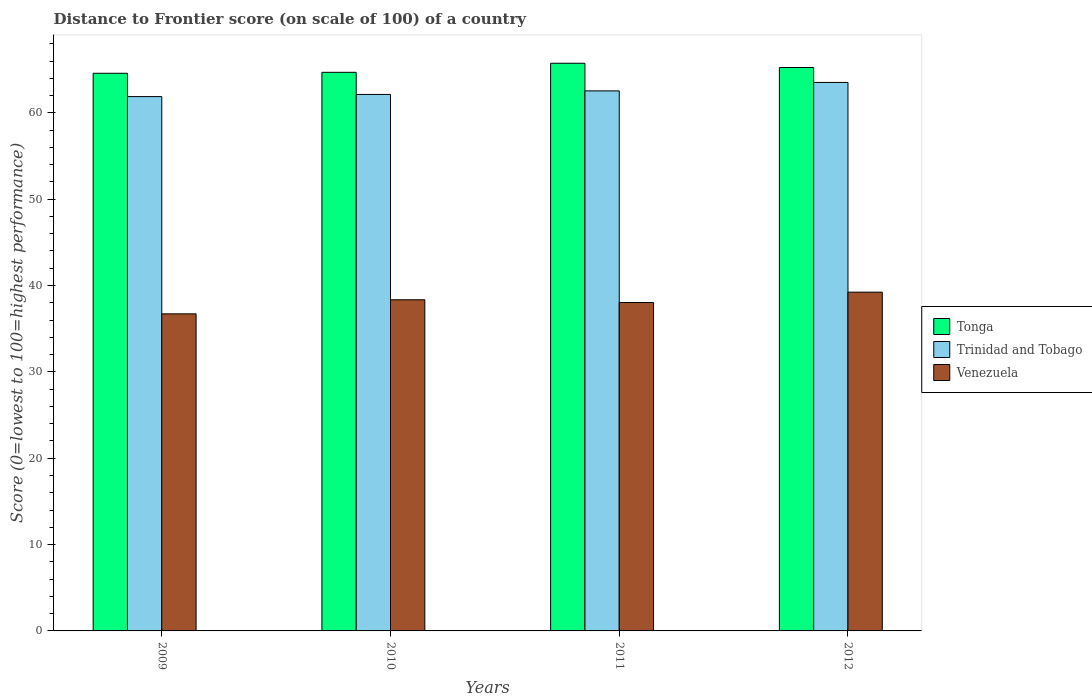How many bars are there on the 1st tick from the right?
Offer a very short reply. 3. What is the distance to frontier score of in Tonga in 2009?
Make the answer very short. 64.58. Across all years, what is the maximum distance to frontier score of in Trinidad and Tobago?
Provide a short and direct response. 63.52. Across all years, what is the minimum distance to frontier score of in Tonga?
Offer a very short reply. 64.58. In which year was the distance to frontier score of in Trinidad and Tobago maximum?
Your response must be concise. 2012. What is the total distance to frontier score of in Venezuela in the graph?
Offer a very short reply. 152.33. What is the difference between the distance to frontier score of in Venezuela in 2009 and that in 2012?
Offer a very short reply. -2.51. What is the difference between the distance to frontier score of in Trinidad and Tobago in 2009 and the distance to frontier score of in Venezuela in 2012?
Your answer should be very brief. 22.65. What is the average distance to frontier score of in Tonga per year?
Offer a very short reply. 65.06. In the year 2011, what is the difference between the distance to frontier score of in Venezuela and distance to frontier score of in Trinidad and Tobago?
Offer a terse response. -24.51. What is the ratio of the distance to frontier score of in Venezuela in 2009 to that in 2012?
Provide a short and direct response. 0.94. What is the difference between the highest and the second highest distance to frontier score of in Tonga?
Your answer should be compact. 0.49. What is the difference between the highest and the lowest distance to frontier score of in Venezuela?
Your answer should be very brief. 2.51. What does the 1st bar from the left in 2010 represents?
Offer a terse response. Tonga. What does the 1st bar from the right in 2010 represents?
Make the answer very short. Venezuela. Is it the case that in every year, the sum of the distance to frontier score of in Trinidad and Tobago and distance to frontier score of in Tonga is greater than the distance to frontier score of in Venezuela?
Your answer should be very brief. Yes. How many years are there in the graph?
Offer a terse response. 4. What is the difference between two consecutive major ticks on the Y-axis?
Your answer should be very brief. 10. Does the graph contain grids?
Provide a succinct answer. No. How are the legend labels stacked?
Offer a terse response. Vertical. What is the title of the graph?
Ensure brevity in your answer.  Distance to Frontier score (on scale of 100) of a country. Does "Algeria" appear as one of the legend labels in the graph?
Keep it short and to the point. No. What is the label or title of the Y-axis?
Offer a terse response. Score (0=lowest to 100=highest performance). What is the Score (0=lowest to 100=highest performance) of Tonga in 2009?
Offer a very short reply. 64.58. What is the Score (0=lowest to 100=highest performance) of Trinidad and Tobago in 2009?
Ensure brevity in your answer.  61.88. What is the Score (0=lowest to 100=highest performance) in Venezuela in 2009?
Give a very brief answer. 36.72. What is the Score (0=lowest to 100=highest performance) of Tonga in 2010?
Your answer should be very brief. 64.69. What is the Score (0=lowest to 100=highest performance) of Trinidad and Tobago in 2010?
Ensure brevity in your answer.  62.13. What is the Score (0=lowest to 100=highest performance) in Venezuela in 2010?
Your answer should be compact. 38.35. What is the Score (0=lowest to 100=highest performance) of Tonga in 2011?
Provide a succinct answer. 65.74. What is the Score (0=lowest to 100=highest performance) of Trinidad and Tobago in 2011?
Give a very brief answer. 62.54. What is the Score (0=lowest to 100=highest performance) of Venezuela in 2011?
Make the answer very short. 38.03. What is the Score (0=lowest to 100=highest performance) of Tonga in 2012?
Your answer should be compact. 65.25. What is the Score (0=lowest to 100=highest performance) of Trinidad and Tobago in 2012?
Your response must be concise. 63.52. What is the Score (0=lowest to 100=highest performance) of Venezuela in 2012?
Your answer should be compact. 39.23. Across all years, what is the maximum Score (0=lowest to 100=highest performance) of Tonga?
Keep it short and to the point. 65.74. Across all years, what is the maximum Score (0=lowest to 100=highest performance) of Trinidad and Tobago?
Offer a very short reply. 63.52. Across all years, what is the maximum Score (0=lowest to 100=highest performance) in Venezuela?
Provide a succinct answer. 39.23. Across all years, what is the minimum Score (0=lowest to 100=highest performance) of Tonga?
Ensure brevity in your answer.  64.58. Across all years, what is the minimum Score (0=lowest to 100=highest performance) of Trinidad and Tobago?
Make the answer very short. 61.88. Across all years, what is the minimum Score (0=lowest to 100=highest performance) of Venezuela?
Give a very brief answer. 36.72. What is the total Score (0=lowest to 100=highest performance) in Tonga in the graph?
Provide a succinct answer. 260.26. What is the total Score (0=lowest to 100=highest performance) of Trinidad and Tobago in the graph?
Keep it short and to the point. 250.07. What is the total Score (0=lowest to 100=highest performance) in Venezuela in the graph?
Ensure brevity in your answer.  152.33. What is the difference between the Score (0=lowest to 100=highest performance) in Tonga in 2009 and that in 2010?
Provide a short and direct response. -0.11. What is the difference between the Score (0=lowest to 100=highest performance) of Trinidad and Tobago in 2009 and that in 2010?
Make the answer very short. -0.25. What is the difference between the Score (0=lowest to 100=highest performance) in Venezuela in 2009 and that in 2010?
Provide a succinct answer. -1.63. What is the difference between the Score (0=lowest to 100=highest performance) of Tonga in 2009 and that in 2011?
Provide a succinct answer. -1.16. What is the difference between the Score (0=lowest to 100=highest performance) in Trinidad and Tobago in 2009 and that in 2011?
Offer a very short reply. -0.66. What is the difference between the Score (0=lowest to 100=highest performance) of Venezuela in 2009 and that in 2011?
Provide a succinct answer. -1.31. What is the difference between the Score (0=lowest to 100=highest performance) of Tonga in 2009 and that in 2012?
Your response must be concise. -0.67. What is the difference between the Score (0=lowest to 100=highest performance) in Trinidad and Tobago in 2009 and that in 2012?
Ensure brevity in your answer.  -1.64. What is the difference between the Score (0=lowest to 100=highest performance) in Venezuela in 2009 and that in 2012?
Provide a short and direct response. -2.51. What is the difference between the Score (0=lowest to 100=highest performance) of Tonga in 2010 and that in 2011?
Provide a succinct answer. -1.05. What is the difference between the Score (0=lowest to 100=highest performance) of Trinidad and Tobago in 2010 and that in 2011?
Your answer should be very brief. -0.41. What is the difference between the Score (0=lowest to 100=highest performance) of Venezuela in 2010 and that in 2011?
Make the answer very short. 0.32. What is the difference between the Score (0=lowest to 100=highest performance) of Tonga in 2010 and that in 2012?
Your answer should be compact. -0.56. What is the difference between the Score (0=lowest to 100=highest performance) in Trinidad and Tobago in 2010 and that in 2012?
Your answer should be very brief. -1.39. What is the difference between the Score (0=lowest to 100=highest performance) of Venezuela in 2010 and that in 2012?
Ensure brevity in your answer.  -0.88. What is the difference between the Score (0=lowest to 100=highest performance) in Tonga in 2011 and that in 2012?
Offer a terse response. 0.49. What is the difference between the Score (0=lowest to 100=highest performance) of Trinidad and Tobago in 2011 and that in 2012?
Offer a very short reply. -0.98. What is the difference between the Score (0=lowest to 100=highest performance) of Tonga in 2009 and the Score (0=lowest to 100=highest performance) of Trinidad and Tobago in 2010?
Provide a short and direct response. 2.45. What is the difference between the Score (0=lowest to 100=highest performance) of Tonga in 2009 and the Score (0=lowest to 100=highest performance) of Venezuela in 2010?
Keep it short and to the point. 26.23. What is the difference between the Score (0=lowest to 100=highest performance) of Trinidad and Tobago in 2009 and the Score (0=lowest to 100=highest performance) of Venezuela in 2010?
Your response must be concise. 23.53. What is the difference between the Score (0=lowest to 100=highest performance) of Tonga in 2009 and the Score (0=lowest to 100=highest performance) of Trinidad and Tobago in 2011?
Your response must be concise. 2.04. What is the difference between the Score (0=lowest to 100=highest performance) of Tonga in 2009 and the Score (0=lowest to 100=highest performance) of Venezuela in 2011?
Provide a short and direct response. 26.55. What is the difference between the Score (0=lowest to 100=highest performance) of Trinidad and Tobago in 2009 and the Score (0=lowest to 100=highest performance) of Venezuela in 2011?
Give a very brief answer. 23.85. What is the difference between the Score (0=lowest to 100=highest performance) in Tonga in 2009 and the Score (0=lowest to 100=highest performance) in Trinidad and Tobago in 2012?
Ensure brevity in your answer.  1.06. What is the difference between the Score (0=lowest to 100=highest performance) of Tonga in 2009 and the Score (0=lowest to 100=highest performance) of Venezuela in 2012?
Make the answer very short. 25.35. What is the difference between the Score (0=lowest to 100=highest performance) in Trinidad and Tobago in 2009 and the Score (0=lowest to 100=highest performance) in Venezuela in 2012?
Make the answer very short. 22.65. What is the difference between the Score (0=lowest to 100=highest performance) in Tonga in 2010 and the Score (0=lowest to 100=highest performance) in Trinidad and Tobago in 2011?
Provide a succinct answer. 2.15. What is the difference between the Score (0=lowest to 100=highest performance) of Tonga in 2010 and the Score (0=lowest to 100=highest performance) of Venezuela in 2011?
Offer a terse response. 26.66. What is the difference between the Score (0=lowest to 100=highest performance) of Trinidad and Tobago in 2010 and the Score (0=lowest to 100=highest performance) of Venezuela in 2011?
Make the answer very short. 24.1. What is the difference between the Score (0=lowest to 100=highest performance) of Tonga in 2010 and the Score (0=lowest to 100=highest performance) of Trinidad and Tobago in 2012?
Keep it short and to the point. 1.17. What is the difference between the Score (0=lowest to 100=highest performance) of Tonga in 2010 and the Score (0=lowest to 100=highest performance) of Venezuela in 2012?
Give a very brief answer. 25.46. What is the difference between the Score (0=lowest to 100=highest performance) in Trinidad and Tobago in 2010 and the Score (0=lowest to 100=highest performance) in Venezuela in 2012?
Your answer should be very brief. 22.9. What is the difference between the Score (0=lowest to 100=highest performance) of Tonga in 2011 and the Score (0=lowest to 100=highest performance) of Trinidad and Tobago in 2012?
Provide a short and direct response. 2.22. What is the difference between the Score (0=lowest to 100=highest performance) of Tonga in 2011 and the Score (0=lowest to 100=highest performance) of Venezuela in 2012?
Ensure brevity in your answer.  26.51. What is the difference between the Score (0=lowest to 100=highest performance) of Trinidad and Tobago in 2011 and the Score (0=lowest to 100=highest performance) of Venezuela in 2012?
Give a very brief answer. 23.31. What is the average Score (0=lowest to 100=highest performance) in Tonga per year?
Your answer should be compact. 65.06. What is the average Score (0=lowest to 100=highest performance) in Trinidad and Tobago per year?
Provide a short and direct response. 62.52. What is the average Score (0=lowest to 100=highest performance) of Venezuela per year?
Offer a terse response. 38.08. In the year 2009, what is the difference between the Score (0=lowest to 100=highest performance) of Tonga and Score (0=lowest to 100=highest performance) of Venezuela?
Give a very brief answer. 27.86. In the year 2009, what is the difference between the Score (0=lowest to 100=highest performance) in Trinidad and Tobago and Score (0=lowest to 100=highest performance) in Venezuela?
Offer a terse response. 25.16. In the year 2010, what is the difference between the Score (0=lowest to 100=highest performance) in Tonga and Score (0=lowest to 100=highest performance) in Trinidad and Tobago?
Provide a succinct answer. 2.56. In the year 2010, what is the difference between the Score (0=lowest to 100=highest performance) in Tonga and Score (0=lowest to 100=highest performance) in Venezuela?
Ensure brevity in your answer.  26.34. In the year 2010, what is the difference between the Score (0=lowest to 100=highest performance) in Trinidad and Tobago and Score (0=lowest to 100=highest performance) in Venezuela?
Your answer should be very brief. 23.78. In the year 2011, what is the difference between the Score (0=lowest to 100=highest performance) in Tonga and Score (0=lowest to 100=highest performance) in Venezuela?
Offer a terse response. 27.71. In the year 2011, what is the difference between the Score (0=lowest to 100=highest performance) in Trinidad and Tobago and Score (0=lowest to 100=highest performance) in Venezuela?
Your response must be concise. 24.51. In the year 2012, what is the difference between the Score (0=lowest to 100=highest performance) in Tonga and Score (0=lowest to 100=highest performance) in Trinidad and Tobago?
Offer a very short reply. 1.73. In the year 2012, what is the difference between the Score (0=lowest to 100=highest performance) in Tonga and Score (0=lowest to 100=highest performance) in Venezuela?
Provide a short and direct response. 26.02. In the year 2012, what is the difference between the Score (0=lowest to 100=highest performance) in Trinidad and Tobago and Score (0=lowest to 100=highest performance) in Venezuela?
Give a very brief answer. 24.29. What is the ratio of the Score (0=lowest to 100=highest performance) in Venezuela in 2009 to that in 2010?
Provide a succinct answer. 0.96. What is the ratio of the Score (0=lowest to 100=highest performance) in Tonga in 2009 to that in 2011?
Your response must be concise. 0.98. What is the ratio of the Score (0=lowest to 100=highest performance) in Venezuela in 2009 to that in 2011?
Ensure brevity in your answer.  0.97. What is the ratio of the Score (0=lowest to 100=highest performance) in Tonga in 2009 to that in 2012?
Make the answer very short. 0.99. What is the ratio of the Score (0=lowest to 100=highest performance) of Trinidad and Tobago in 2009 to that in 2012?
Offer a terse response. 0.97. What is the ratio of the Score (0=lowest to 100=highest performance) in Venezuela in 2009 to that in 2012?
Your response must be concise. 0.94. What is the ratio of the Score (0=lowest to 100=highest performance) of Tonga in 2010 to that in 2011?
Provide a short and direct response. 0.98. What is the ratio of the Score (0=lowest to 100=highest performance) in Venezuela in 2010 to that in 2011?
Provide a short and direct response. 1.01. What is the ratio of the Score (0=lowest to 100=highest performance) of Tonga in 2010 to that in 2012?
Keep it short and to the point. 0.99. What is the ratio of the Score (0=lowest to 100=highest performance) of Trinidad and Tobago in 2010 to that in 2012?
Ensure brevity in your answer.  0.98. What is the ratio of the Score (0=lowest to 100=highest performance) of Venezuela in 2010 to that in 2012?
Give a very brief answer. 0.98. What is the ratio of the Score (0=lowest to 100=highest performance) in Tonga in 2011 to that in 2012?
Your response must be concise. 1.01. What is the ratio of the Score (0=lowest to 100=highest performance) in Trinidad and Tobago in 2011 to that in 2012?
Make the answer very short. 0.98. What is the ratio of the Score (0=lowest to 100=highest performance) of Venezuela in 2011 to that in 2012?
Offer a terse response. 0.97. What is the difference between the highest and the second highest Score (0=lowest to 100=highest performance) of Tonga?
Provide a succinct answer. 0.49. What is the difference between the highest and the second highest Score (0=lowest to 100=highest performance) in Trinidad and Tobago?
Make the answer very short. 0.98. What is the difference between the highest and the second highest Score (0=lowest to 100=highest performance) in Venezuela?
Your answer should be compact. 0.88. What is the difference between the highest and the lowest Score (0=lowest to 100=highest performance) in Tonga?
Make the answer very short. 1.16. What is the difference between the highest and the lowest Score (0=lowest to 100=highest performance) of Trinidad and Tobago?
Your answer should be compact. 1.64. What is the difference between the highest and the lowest Score (0=lowest to 100=highest performance) of Venezuela?
Ensure brevity in your answer.  2.51. 